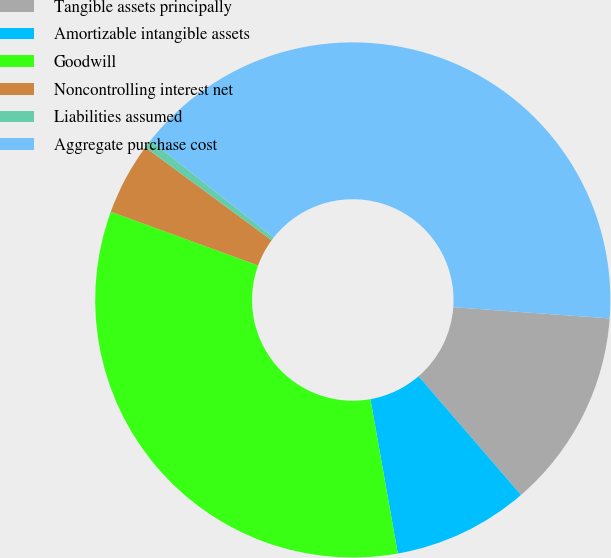Convert chart. <chart><loc_0><loc_0><loc_500><loc_500><pie_chart><fcel>Tangible assets principally<fcel>Amortizable intangible assets<fcel>Goodwill<fcel>Noncontrolling interest net<fcel>Liabilities assumed<fcel>Aggregate purchase cost<nl><fcel>12.53%<fcel>8.53%<fcel>33.36%<fcel>4.53%<fcel>0.53%<fcel>40.52%<nl></chart> 